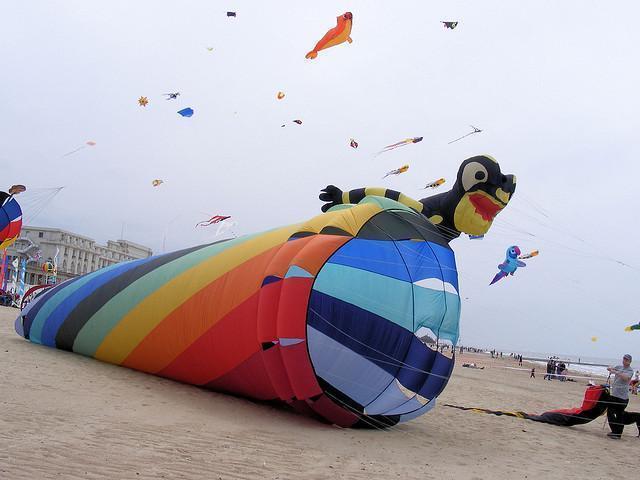What is the large item on the sand shaped like?
Choose the right answer from the provided options to respond to the question.
Options: Ant, basketball, elephant, traffic cone. Traffic cone. 